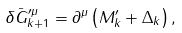<formula> <loc_0><loc_0><loc_500><loc_500>\delta \bar { G } _ { k + 1 } ^ { \prime \mu } = \partial ^ { \mu } \left ( M _ { k } ^ { \prime } + \Delta _ { k } \right ) ,</formula> 